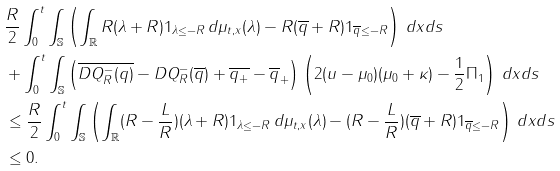<formula> <loc_0><loc_0><loc_500><loc_500>& \frac { R } { 2 } \int _ { 0 } ^ { t } \int _ { \mathbb { S } } \left ( \int _ { \mathbb { R } } R ( \lambda + R ) { 1 } _ { \lambda \leq - R } \, d \mu _ { t , x } ( \lambda ) - R ( \overline { q } + R ) { 1 } _ { \overline { q } \leq - R } \right ) \, d x d s \\ & + \int _ { 0 } ^ { t } \int _ { \mathbb { S } } \left ( \overline { D Q _ { R } ^ { - } ( q ) } - D Q _ { R } ^ { - } ( \overline { q } ) + \overline { q _ { + } } - \overline { q } _ { + } \right ) \left ( 2 ( u - \mu _ { 0 } ) ( \mu _ { 0 } + \kappa ) - \frac { 1 } { 2 } \Pi _ { 1 } \right ) \, d x d s \\ & \leq \frac { R } { 2 } \int _ { 0 } ^ { t } \int _ { \mathbb { S } } \left ( \int _ { \mathbb { R } } ( R - \frac { L } { R } ) ( \lambda + R ) { 1 } _ { \lambda \leq - R } \, d \mu _ { t , x } ( \lambda ) - ( R - \frac { L } { R } ) ( \overline { q } + R ) { 1 } _ { \overline { q } \leq - R } \right ) \, d x d s \\ & \leq 0 .</formula> 